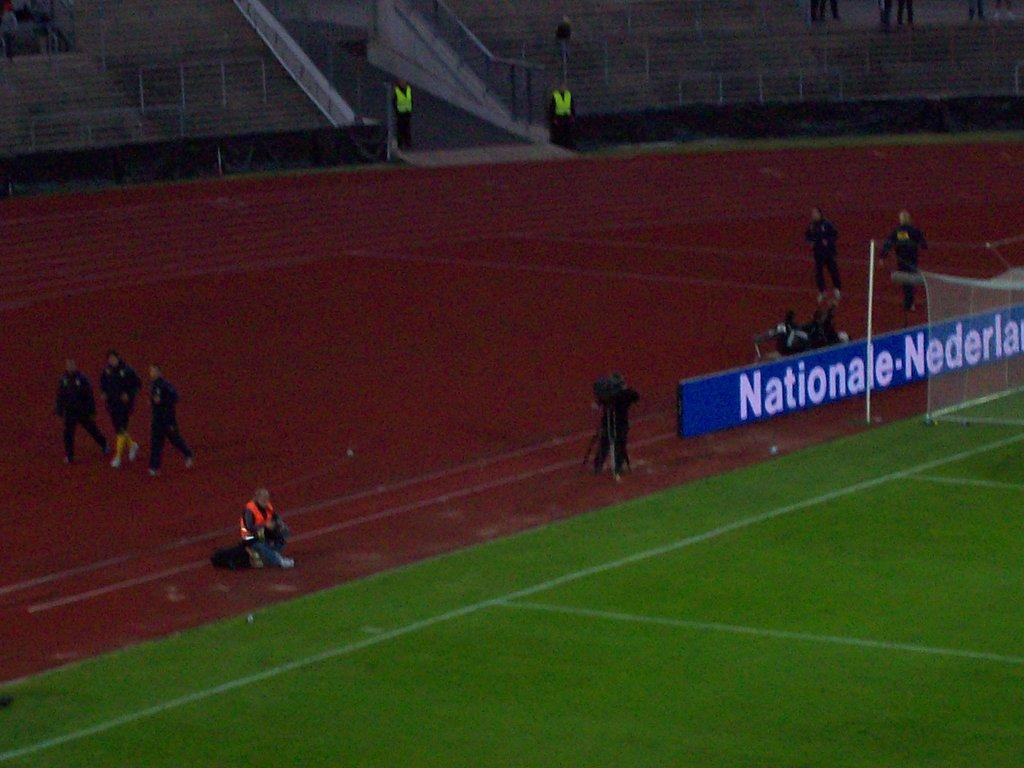<image>
Relay a brief, clear account of the picture shown. People on a playing field with a sign that says nationale. 